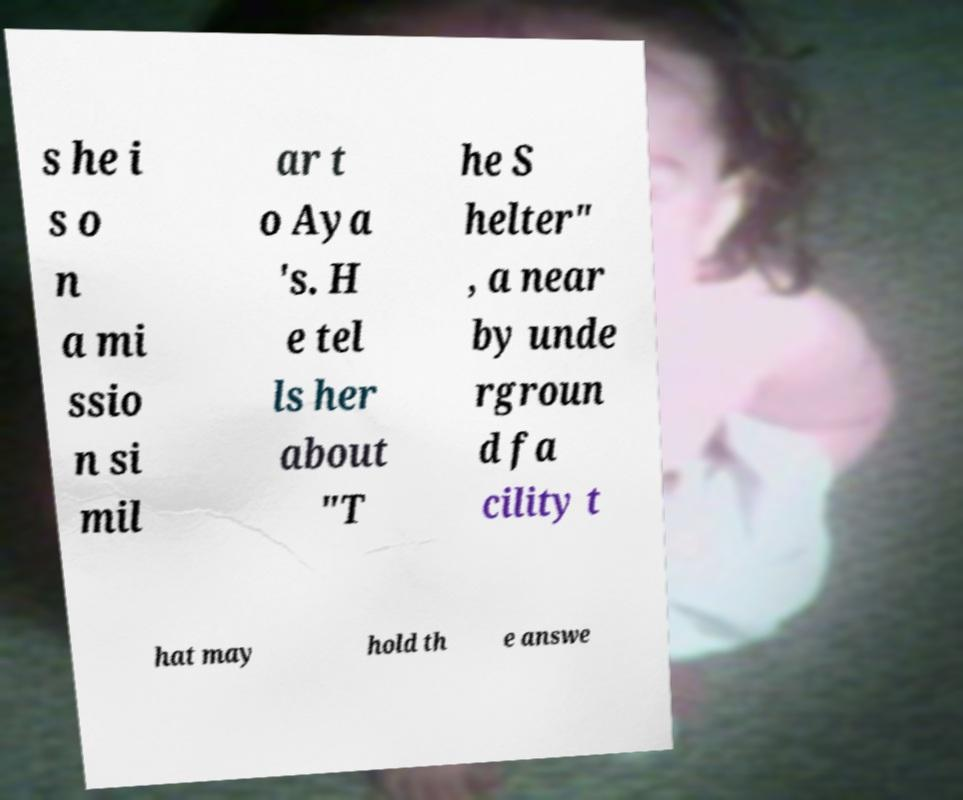Please read and relay the text visible in this image. What does it say? s he i s o n a mi ssio n si mil ar t o Aya 's. H e tel ls her about "T he S helter" , a near by unde rgroun d fa cility t hat may hold th e answe 